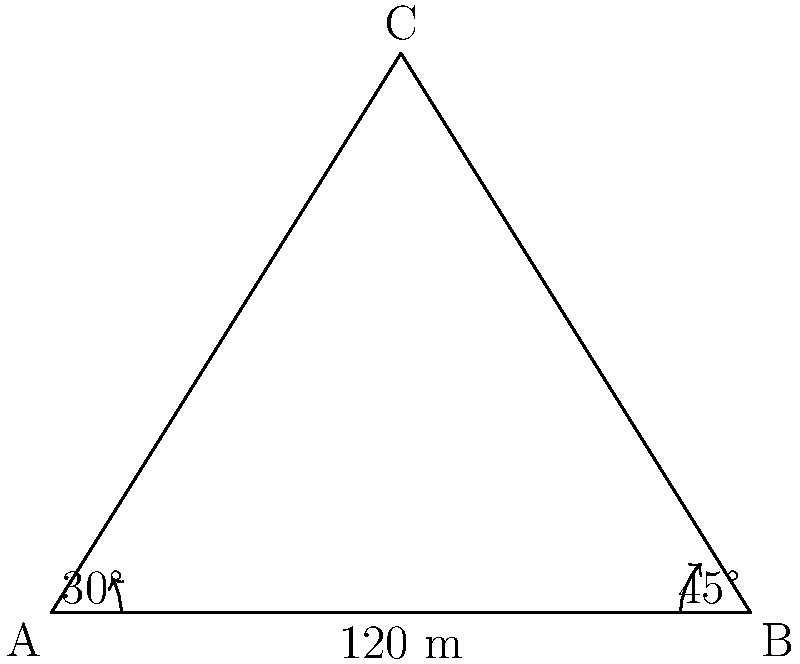In a property dispute novel, a triangular plot of land is described with the following measurements: the base of the triangle (side AB) is 120 meters long, angle A is 30°, and angle B is 45°. Using the law of sines, calculate the length of side AC to the nearest meter. To solve this problem using the law of sines, we'll follow these steps:

1) First, recall the law of sines: 
   $$\frac{a}{\sin A} = \frac{b}{\sin B} = \frac{c}{\sin C}$$
   where a, b, and c are the lengths of the sides opposite to angles A, B, and C respectively.

2) We know:
   - Side AB (c) = 120 m
   - Angle A = 30°
   - Angle B = 45°

3) We can find angle C:
   $$C = 180° - (A + B) = 180° - (30° + 45°) = 105°$$

4) Now we can use the law of sines to find side AC (b):
   $$\frac{b}{\sin B} = \frac{c}{\sin C}$$

5) Rearranging to solve for b:
   $$b = \frac{c \sin B}{\sin C}$$

6) Plugging in the values:
   $$b = \frac{120 \sin 45°}{\sin 105°}$$

7) Calculate:
   $$b = \frac{120 \cdot 0.7071}{0.9659} \approx 87.85$$

8) Rounding to the nearest meter:
   $$b \approx 88 \text{ meters}$$

Therefore, the length of side AC is approximately 88 meters.
Answer: 88 meters 